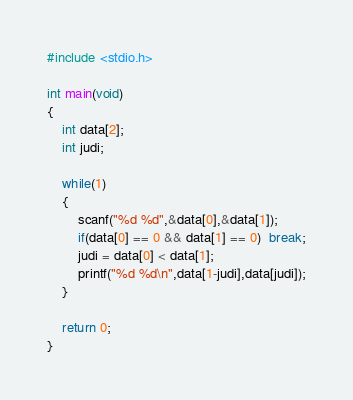<code> <loc_0><loc_0><loc_500><loc_500><_C_>#include <stdio.h>

int main(void)
{
    int data[2];
    int judi;
    
    while(1)
    {
        scanf("%d %d",&data[0],&data[1]);
        if(data[0] == 0 && data[1] == 0)  break;
        judi = data[0] < data[1];
        printf("%d %d\n",data[1-judi],data[judi]);
    }
    
    return 0;
}

</code> 